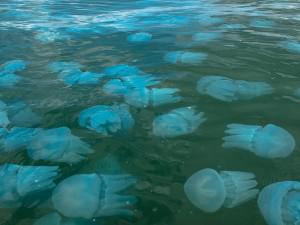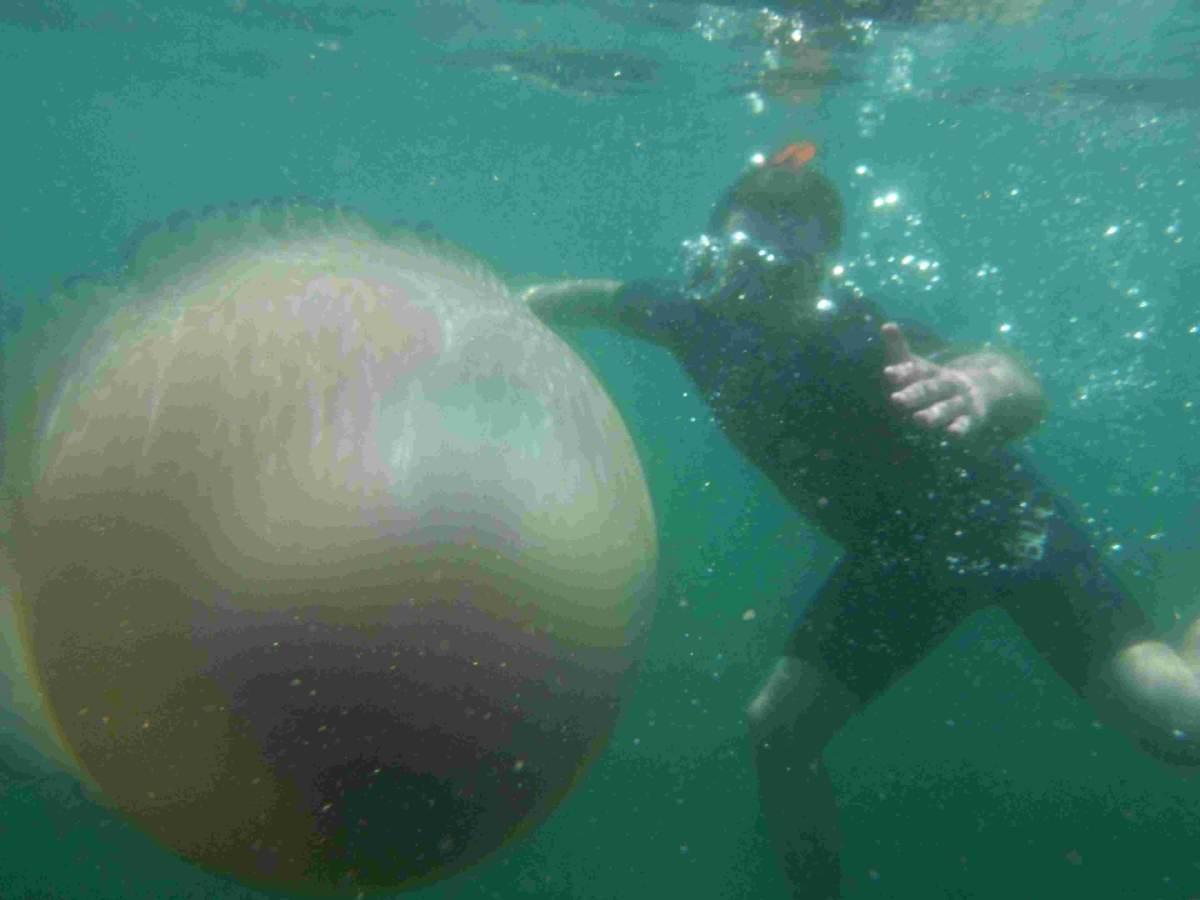The first image is the image on the left, the second image is the image on the right. Assess this claim about the two images: "One image shows a person in a scuba suit holding something up next to a large mushroom-capped jellyfish with its tentacles trailing diagonally downward to the right.". Correct or not? Answer yes or no. No. 